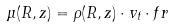<formula> <loc_0><loc_0><loc_500><loc_500>\mu ( R , z ) = \rho ( R , z ) \cdot v _ { t } \cdot f r</formula> 